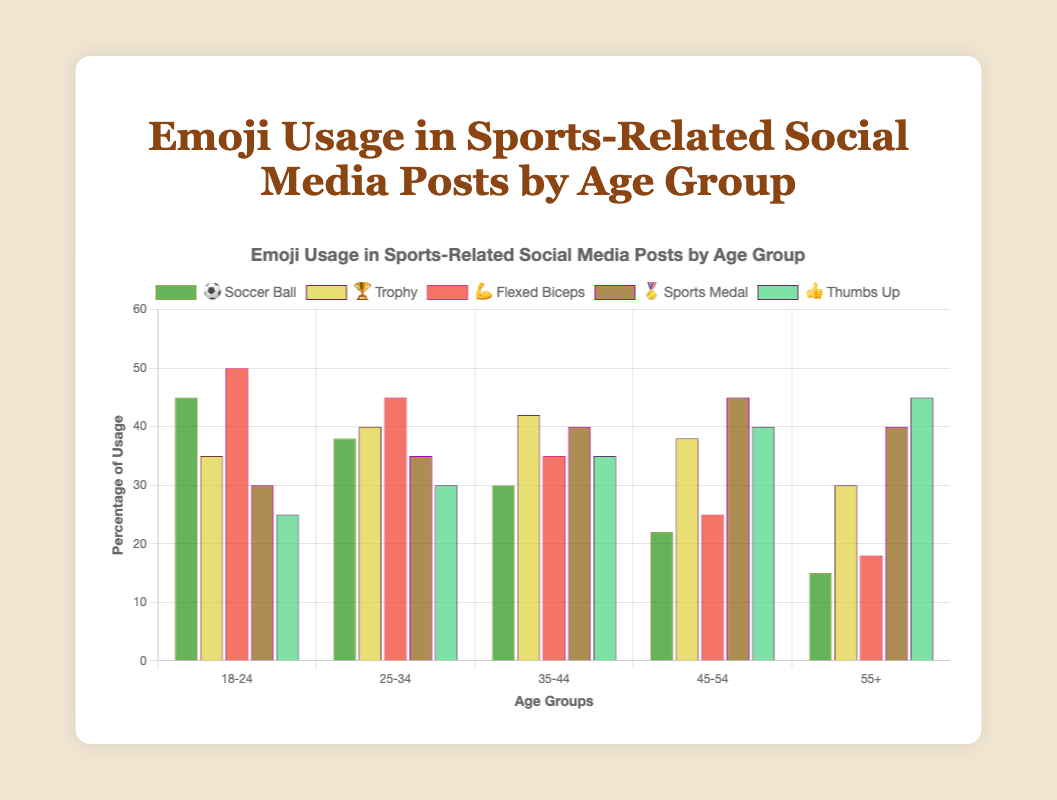What is the most used emoji in the 18-24 age group? The bars in the chart can be observed for the 18-24 age group. The highest bar corresponds to the "💪 Flexed Biceps" emoji at 50%.
Answer: Flexed Biceps 💪 Which emoji shows an increasing trend in usage as age increases? By observing the bars for each emoji across the age groups, we notice that the "👍 Thumbs Up" emoji shows a consistent increase from 25% in the 18-24 group to 45% in the 55+ group.
Answer: Thumbs Up 👍 What is the average percentage usage of the "🏆 Trophy" emoji across all age groups? The percentage usage for the "🏆 Trophy" emoji is given as [35, 40, 42, 38, 30]. The sum of these values is 185. The average is 185 / 5 = 37%.
Answer: 37% Which age group uses the "⚽ Soccer Ball" emoji the least? The bars for the "⚽ Soccer Ball" emoji show that the 55+ age group has the lowest percentage at 15%.
Answer: 55+ What is the difference in percentage between the highest and lowest usage of the "😭 Crying Face" emoji across all age groups? First sum up the highest and lowest usage values based on the given percentages of emojis: highest is 50% (Flexed Biceps 💪 in 18-24), lowest is 15% (Soccer Ball ⚽ and Flexed Biceps 💪 in 55+). The difference is 50 - 15 = 35%.
Answer: 35% What is the combined usage percentage of the "🏅 Sports Medal" emoji in the 35-44 and 45-54 age groups? The "🏅 Sports Medal" emoji usage in the 35-44 age group is 40%, and in the 45-54 age group is 45%. The combined total is 40 + 45 = 85%.
Answer: 85% Which age group has the most balanced usage of different emojis (least variation in percentages)? To find the most balanced usage, observe the variation in usage percentages for each age group. The 45-54 age group shows the most balanced distribution: 22% to 45%.
Answer: 45-54 For the "💪 Flexed Biceps" emoji, what is the percentage difference between the 18-24 and 45-54 age groups? The usage for the "💪 Flexed Biceps" emoji in the 18-24 age group is 50%, and in the 45-54 age group is 25%. The difference is 50 - 25 = 25%.
Answer: 25% Which emoji has the least overall variation in percentage usage across all age groups? The emoji with the least variation will have close percentages across all age groups. The "🏆 Trophy" emoji varies from 30% to 42% (12% difference), which is relatively small.
Answer: Trophy 🏆 What is the trend of the "🏅 Sports Medal" emoji usage from age group 18-24 to 55+? Observing the percentages of the "🏅 Sports Medal" emoji from 18-24 to 55+, we notice an increasing trend from 30% to 40%, before slightly decreasing to a stable rate of 40%.
Answer: Increasing then stable 